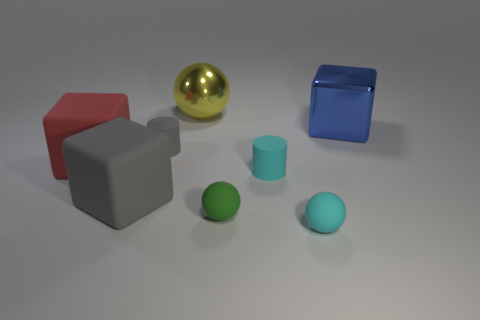What color is the other large thing that is made of the same material as the red thing?
Your answer should be very brief. Gray. How many rubber things are small green things or big red blocks?
Provide a succinct answer. 2. What is the shape of the green object that is the same size as the gray matte cylinder?
Your answer should be compact. Sphere. How many things are either matte balls in front of the green object or rubber balls that are to the right of the green object?
Ensure brevity in your answer.  1. There is a red block that is the same size as the gray rubber cube; what is its material?
Keep it short and to the point. Rubber. What number of other things are there of the same material as the small gray cylinder
Give a very brief answer. 5. Are there the same number of gray cylinders on the right side of the red block and large gray rubber objects to the right of the small cyan ball?
Offer a very short reply. No. How many cyan things are either matte things or tiny rubber spheres?
Your response must be concise. 2. There is a metallic ball; is it the same color as the matte sphere that is right of the small cyan rubber cylinder?
Offer a very short reply. No. How many other objects are there of the same color as the big metallic ball?
Offer a very short reply. 0. 